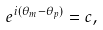Convert formula to latex. <formula><loc_0><loc_0><loc_500><loc_500>e ^ { i ( \theta _ { m } - \theta _ { p } ) } = c ,</formula> 